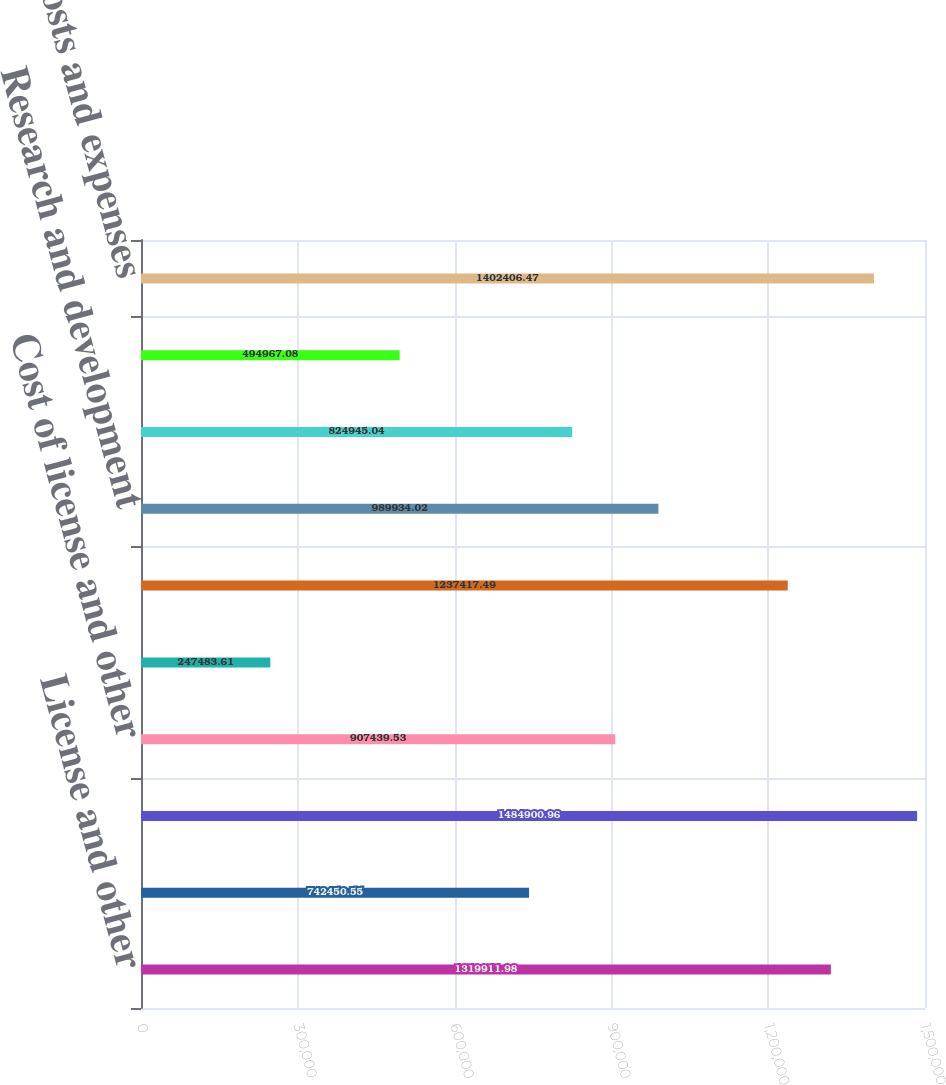<chart> <loc_0><loc_0><loc_500><loc_500><bar_chart><fcel>License and other<fcel>Maintenance<fcel>Total net revenues<fcel>Cost of license and other<fcel>Cost of maintenance revenues<fcel>Marketing and sales<fcel>Research and development<fcel>General and administrative<fcel>Restructuring<fcel>Total costs and expenses<nl><fcel>1.31991e+06<fcel>742451<fcel>1.4849e+06<fcel>907440<fcel>247484<fcel>1.23742e+06<fcel>989934<fcel>824945<fcel>494967<fcel>1.40241e+06<nl></chart> 